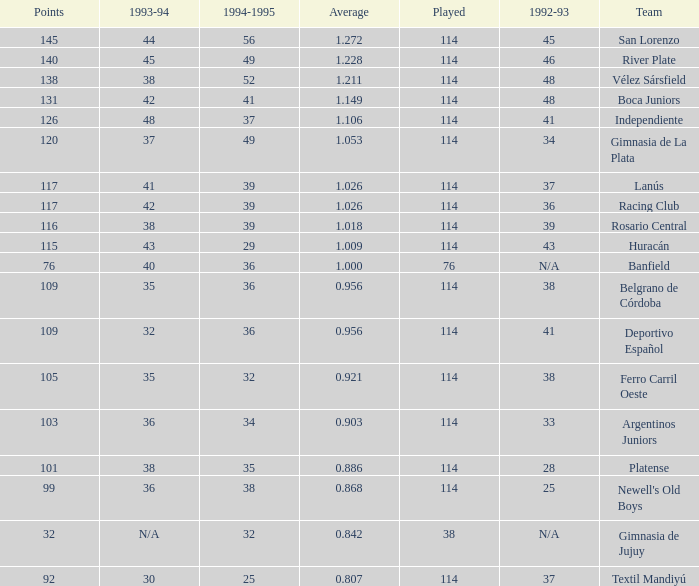Name the team for 1993-94 for 32 Deportivo Español. 